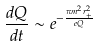<formula> <loc_0><loc_0><loc_500><loc_500>\frac { d Q } { d t } \sim e ^ { - \frac { \pi m ^ { 2 } r _ { + } ^ { 2 } } { e Q } }</formula> 